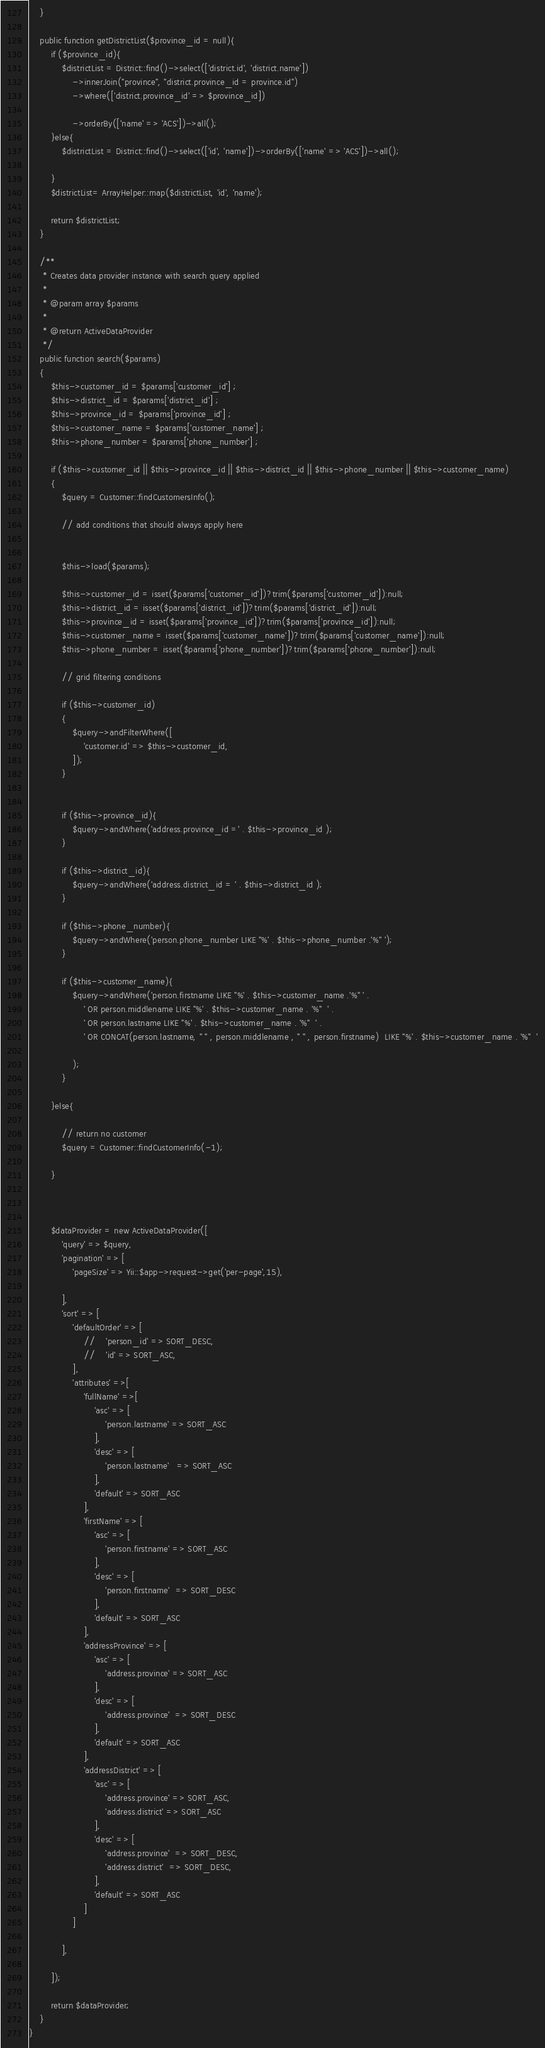Convert code to text. <code><loc_0><loc_0><loc_500><loc_500><_PHP_>    }

    public function getDistrictList($province_id = null){
        if ($province_id){
            $districtList = District::find()->select(['district.id', 'district.name'])
                ->innerJoin("province", "district.province_id = province.id")
                ->where(['district.province_id' => $province_id])

                ->orderBy(['name' => 'ACS'])->all();
        }else{
            $districtList = District::find()->select(['id', 'name'])->orderBy(['name' => 'ACS'])->all();

        }
        $districtList= ArrayHelper::map($districtList, 'id', 'name');

        return $districtList;
    }

    /**
     * Creates data provider instance with search query applied
     *
     * @param array $params
     *
     * @return ActiveDataProvider
     */
    public function search($params)
    {
        $this->customer_id = $params['customer_id'] ;
        $this->district_id = $params['district_id'] ;
        $this->province_id = $params['province_id'] ;
        $this->customer_name = $params['customer_name'] ;
        $this->phone_number = $params['phone_number'] ;

        if ($this->customer_id || $this->province_id || $this->district_id || $this->phone_number || $this->customer_name)
        {
            $query = Customer::findCustomersInfo();

            // add conditions that should always apply here


            $this->load($params);

            $this->customer_id = isset($params['customer_id'])?trim($params['customer_id']):null;
            $this->district_id = isset($params['district_id'])?trim($params['district_id']):null;
            $this->province_id = isset($params['province_id'])?trim($params['province_id']):null;
            $this->customer_name = isset($params['customer_name'])?trim($params['customer_name']):null;
            $this->phone_number = isset($params['phone_number'])?trim($params['phone_number']):null;

            // grid filtering conditions

            if ($this->customer_id)
            {
                $query->andFilterWhere([
                    'customer.id' => $this->customer_id,
                ]);
            }


            if ($this->province_id){
                $query->andWhere('address.province_id =' . $this->province_id );
            }

            if ($this->district_id){
                $query->andWhere('address.district_id = ' . $this->district_id );
            }

            if ($this->phone_number){
                $query->andWhere('person.phone_number LIKE "%' . $this->phone_number .'%" ');
            }

            if ($this->customer_name){
                $query->andWhere('person.firstname LIKE "%' . $this->customer_name .'%" ' .
                    ' OR person.middlename LIKE "%' . $this->customer_name . '%"  ' .
                    ' OR person.lastname LIKE "%' . $this->customer_name . '%"  ' .
                    ' OR CONCAT(person.lastname, " " , person.middlename , " " , person.firstname)  LIKE "%' . $this->customer_name . '%"  '

                );
            }

        }else{

            // return no customer
            $query = Customer::findCustomerInfo(-1);

        }



        $dataProvider = new ActiveDataProvider([
            'query' => $query,
            'pagination' => [
                'pageSize' => Yii::$app->request->get('per-page',15),

            ],
            'sort' => [
                'defaultOrder' => [
                    //    'person_id' => SORT_DESC,
                    //    'id' => SORT_ASC,
                ],
                'attributes' =>[
                    'fullName' =>[
                        'asc' => [
                            'person.lastname' => SORT_ASC
                        ],
                        'desc' => [
                            'person.lastname'   => SORT_ASC
                        ],
                        'default' => SORT_ASC
                    ],
                    'firstName' => [
                        'asc' => [
                            'person.firstname' => SORT_ASC
                        ],
                        'desc' => [
                            'person.firstname'  => SORT_DESC
                        ],
                        'default' => SORT_ASC
                    ],
                    'addressProvince' => [
                        'asc' => [
                            'address.province' => SORT_ASC
                        ],
                        'desc' => [
                            'address.province'  => SORT_DESC
                        ],
                        'default' => SORT_ASC
                    ],
                    'addressDistrict' => [
                        'asc' => [
                            'address.province' => SORT_ASC,
                            'address.district' => SORT_ASC
                        ],
                        'desc' => [
                            'address.province'  => SORT_DESC,
                            'address.district'  => SORT_DESC,
                        ],
                        'default' => SORT_ASC
                    ]
                ]

            ],

        ]);

        return $dataProvider;
    }
}
</code> 